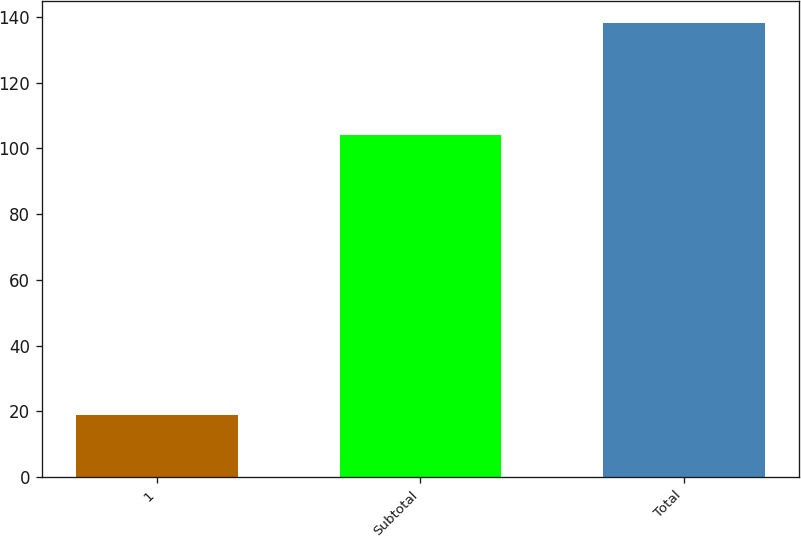Convert chart. <chart><loc_0><loc_0><loc_500><loc_500><bar_chart><fcel>1<fcel>Subtotal<fcel>Total<nl><fcel>19<fcel>104<fcel>138<nl></chart> 